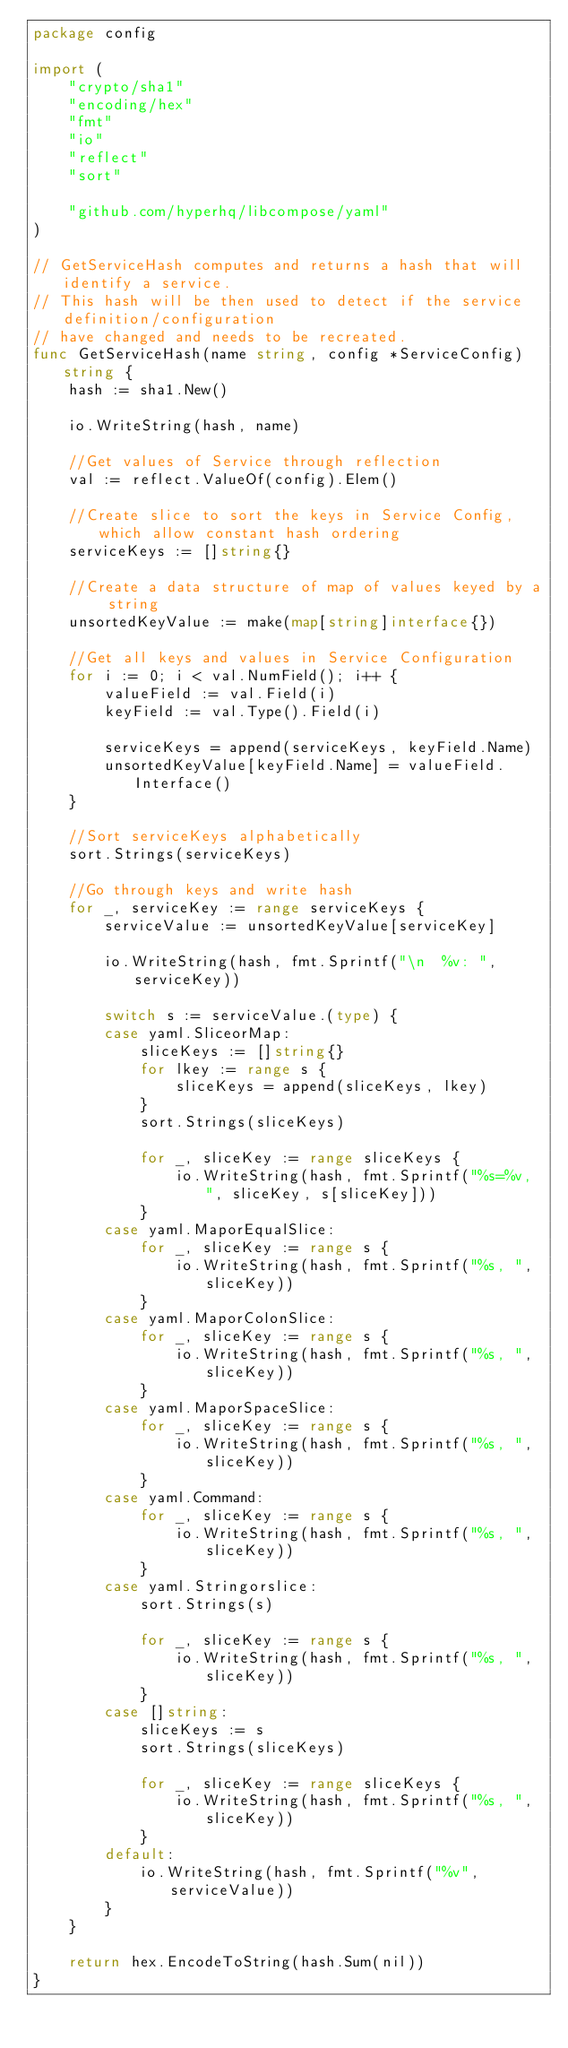<code> <loc_0><loc_0><loc_500><loc_500><_Go_>package config

import (
	"crypto/sha1"
	"encoding/hex"
	"fmt"
	"io"
	"reflect"
	"sort"

	"github.com/hyperhq/libcompose/yaml"
)

// GetServiceHash computes and returns a hash that will identify a service.
// This hash will be then used to detect if the service definition/configuration
// have changed and needs to be recreated.
func GetServiceHash(name string, config *ServiceConfig) string {
	hash := sha1.New()

	io.WriteString(hash, name)

	//Get values of Service through reflection
	val := reflect.ValueOf(config).Elem()

	//Create slice to sort the keys in Service Config, which allow constant hash ordering
	serviceKeys := []string{}

	//Create a data structure of map of values keyed by a string
	unsortedKeyValue := make(map[string]interface{})

	//Get all keys and values in Service Configuration
	for i := 0; i < val.NumField(); i++ {
		valueField := val.Field(i)
		keyField := val.Type().Field(i)

		serviceKeys = append(serviceKeys, keyField.Name)
		unsortedKeyValue[keyField.Name] = valueField.Interface()
	}

	//Sort serviceKeys alphabetically
	sort.Strings(serviceKeys)

	//Go through keys and write hash
	for _, serviceKey := range serviceKeys {
		serviceValue := unsortedKeyValue[serviceKey]

		io.WriteString(hash, fmt.Sprintf("\n  %v: ", serviceKey))

		switch s := serviceValue.(type) {
		case yaml.SliceorMap:
			sliceKeys := []string{}
			for lkey := range s {
				sliceKeys = append(sliceKeys, lkey)
			}
			sort.Strings(sliceKeys)

			for _, sliceKey := range sliceKeys {
				io.WriteString(hash, fmt.Sprintf("%s=%v, ", sliceKey, s[sliceKey]))
			}
		case yaml.MaporEqualSlice:
			for _, sliceKey := range s {
				io.WriteString(hash, fmt.Sprintf("%s, ", sliceKey))
			}
		case yaml.MaporColonSlice:
			for _, sliceKey := range s {
				io.WriteString(hash, fmt.Sprintf("%s, ", sliceKey))
			}
		case yaml.MaporSpaceSlice:
			for _, sliceKey := range s {
				io.WriteString(hash, fmt.Sprintf("%s, ", sliceKey))
			}
		case yaml.Command:
			for _, sliceKey := range s {
				io.WriteString(hash, fmt.Sprintf("%s, ", sliceKey))
			}
		case yaml.Stringorslice:
			sort.Strings(s)

			for _, sliceKey := range s {
				io.WriteString(hash, fmt.Sprintf("%s, ", sliceKey))
			}
		case []string:
			sliceKeys := s
			sort.Strings(sliceKeys)

			for _, sliceKey := range sliceKeys {
				io.WriteString(hash, fmt.Sprintf("%s, ", sliceKey))
			}
		default:
			io.WriteString(hash, fmt.Sprintf("%v", serviceValue))
		}
	}

	return hex.EncodeToString(hash.Sum(nil))
}
</code> 